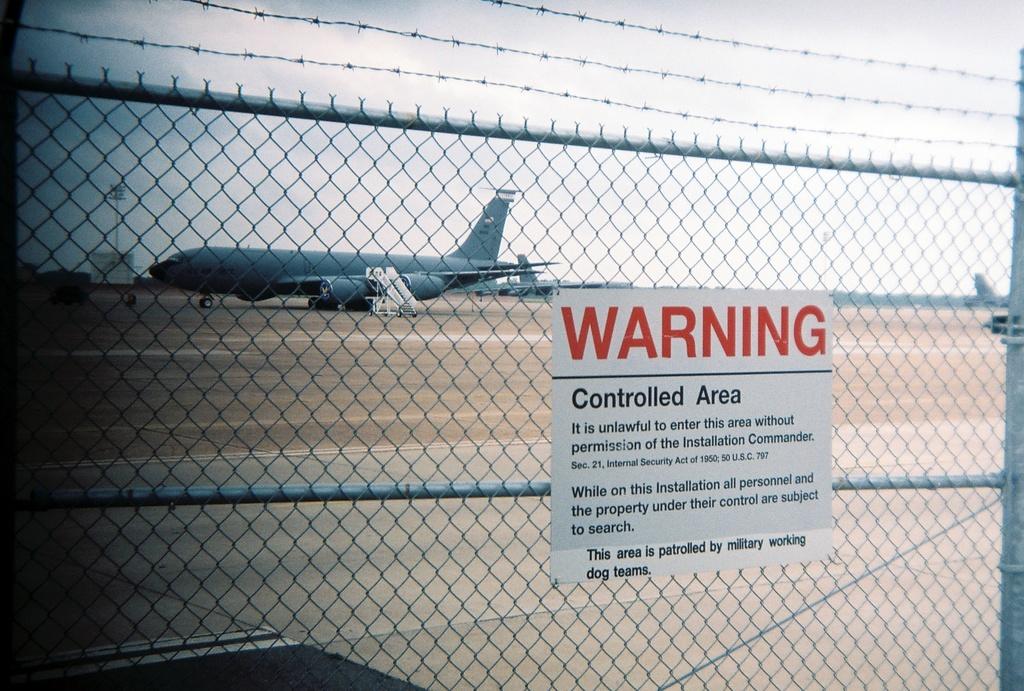What is printed in red?
Offer a terse response. Warning. What type of area is it?
Ensure brevity in your answer.  Controlled. 